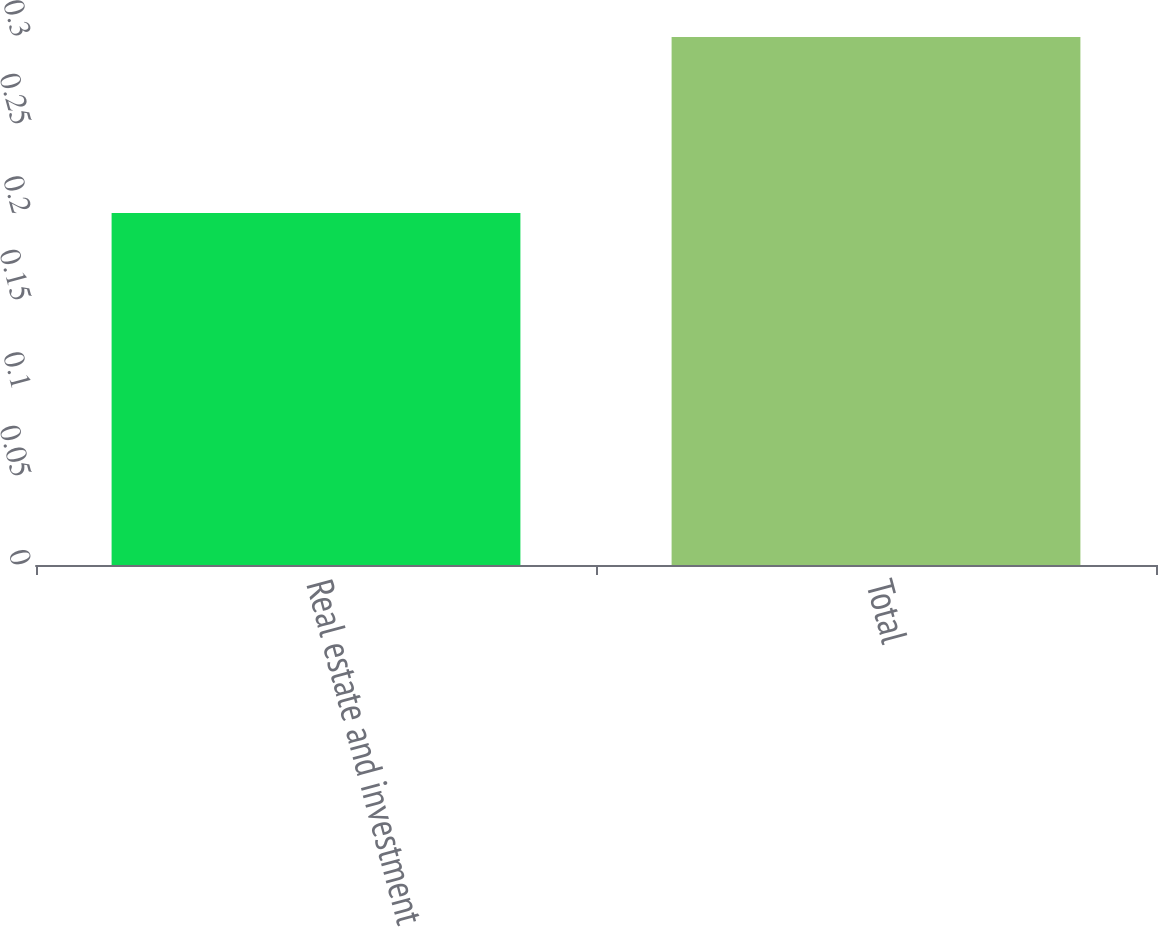Convert chart to OTSL. <chart><loc_0><loc_0><loc_500><loc_500><bar_chart><fcel>Real estate and investment<fcel>Total<nl><fcel>0.2<fcel>0.3<nl></chart> 